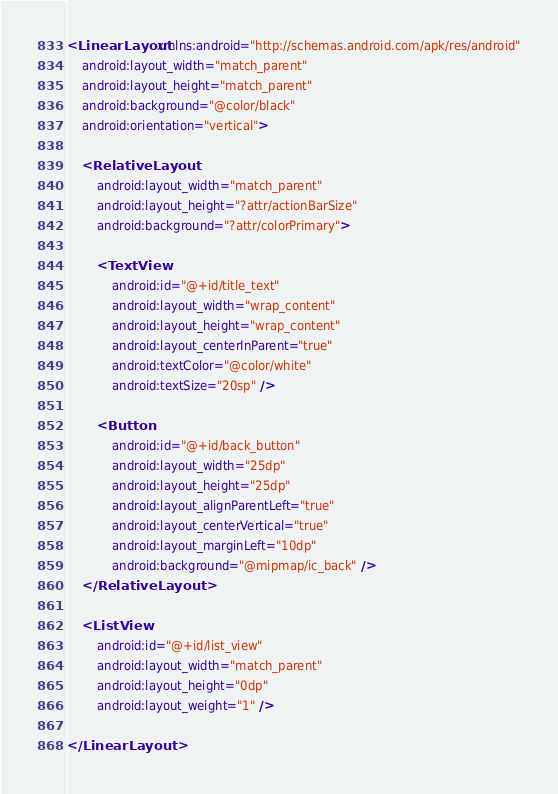<code> <loc_0><loc_0><loc_500><loc_500><_XML_><LinearLayout xmlns:android="http://schemas.android.com/apk/res/android"
    android:layout_width="match_parent"
    android:layout_height="match_parent"
    android:background="@color/black"
    android:orientation="vertical">

    <RelativeLayout
        android:layout_width="match_parent"
        android:layout_height="?attr/actionBarSize"
        android:background="?attr/colorPrimary">

        <TextView
            android:id="@+id/title_text"
            android:layout_width="wrap_content"
            android:layout_height="wrap_content"
            android:layout_centerInParent="true"
            android:textColor="@color/white"
            android:textSize="20sp" />

        <Button
            android:id="@+id/back_button"
            android:layout_width="25dp"
            android:layout_height="25dp"
            android:layout_alignParentLeft="true"
            android:layout_centerVertical="true"
            android:layout_marginLeft="10dp"
            android:background="@mipmap/ic_back" />
    </RelativeLayout>

    <ListView
        android:id="@+id/list_view"
        android:layout_width="match_parent"
        android:layout_height="0dp"
        android:layout_weight="1" />

</LinearLayout></code> 